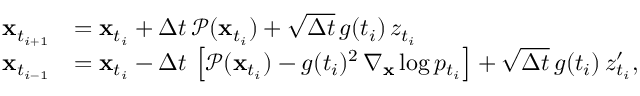Convert formula to latex. <formula><loc_0><loc_0><loc_500><loc_500>\begin{array} { r l } { x _ { t _ { i + 1 } } } & { = x _ { t _ { i } } + \Delta t \, \mathcal { P } ( x _ { t _ { i } } ) + \sqrt { \Delta t } \, g ( t _ { i } ) \, z _ { t _ { i } } } \\ { x _ { t _ { i - 1 } } } & { = x _ { t _ { i } } - \Delta t \, \left [ \mathcal { P } ( x _ { t _ { i } } ) - g ( t _ { i } ) ^ { 2 } \, \nabla _ { x } \log p _ { t _ { i } } \right ] + \sqrt { \Delta t } \, g ( { t _ { i } } ) \, z _ { t _ { i } } ^ { \prime } , } \end{array}</formula> 